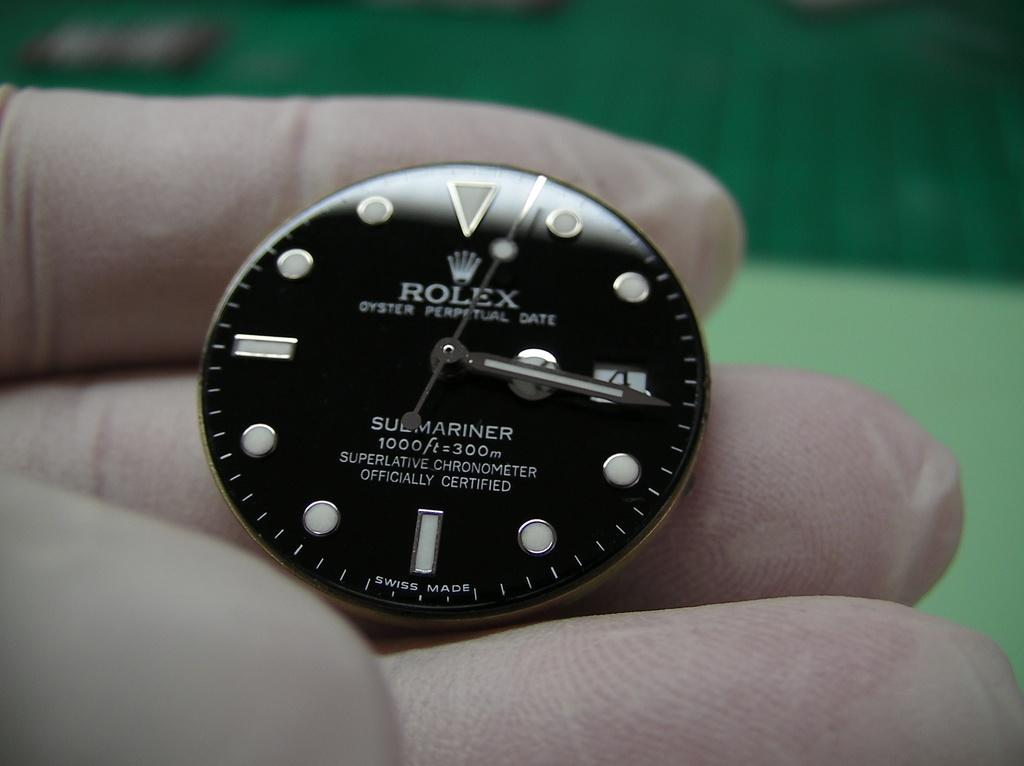<image>
Describe the image concisely. Person holding a black face for a watch which says ROLEX on it. 